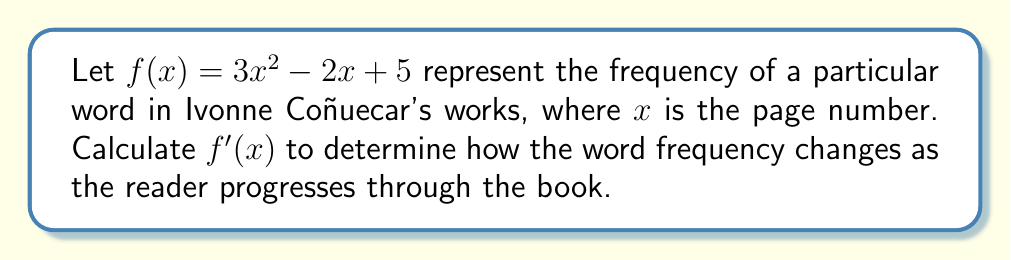Provide a solution to this math problem. To find the derivative of $f(x)$, we'll use the power rule and the constant rule:

1) For the term $3x^2$:
   The power rule states that the derivative of $x^n$ is $nx^{n-1}$.
   So, the derivative of $3x^2$ is $3 \cdot 2x^{2-1} = 6x$.

2) For the term $-2x$:
   The power rule applies here as well, with $n=1$.
   The derivative of $-2x$ is $-2 \cdot 1x^{1-1} = -2$.

3) For the constant term $5$:
   The derivative of a constant is always 0.

4) Combining these results:
   $f'(x) = 6x - 2 + 0 = 6x - 2$

This derivative represents the rate of change of the word frequency as the page number increases. A positive value indicates the word is becoming more frequent, while a negative value suggests it's becoming less frequent.
Answer: $f'(x) = 6x - 2$ 